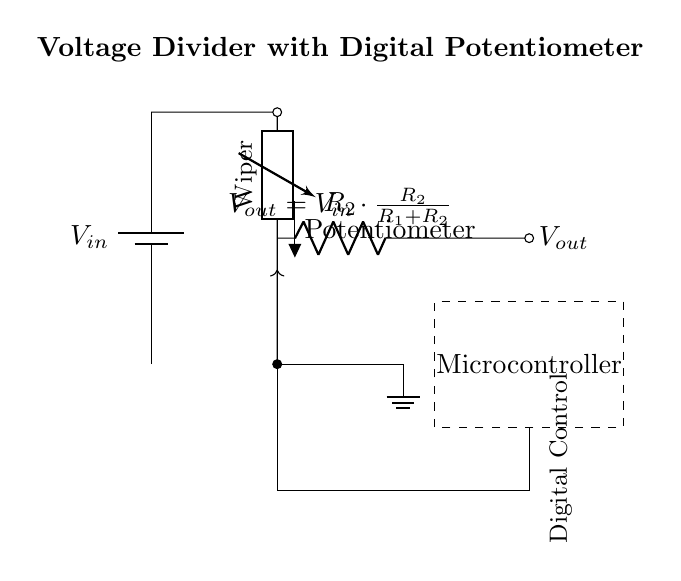What is the input voltage source? The input voltage source is labeled as V_in, indicating it is the voltage supplied to the circuit.
Answer: V_in What type of potentiometer is used in this circuit? The potentiometer is specified as a digital potentiometer, which is indicated by the label in the circuit design.
Answer: Digital What is the value of V_out based on the given formula? V_out is calculated using the formula V_out = V_in * (R_2 / (R_1 + R_2)), which relates the output voltage to the resistance values and input voltage.
Answer: V_out formula What role does the microcontroller play in this circuit? The microcontroller is responsible for controlling the digital potentiometer, adjusting the output voltage based on commands or settings it receives.
Answer: Control What is the purpose of the resistor labeled R_2? The resistor R_2 is part of the voltage divider network that, along with another resistor, determines the output voltage V_out relative to the input voltage V_in.
Answer: Voltage division How does changing the resistance of the digital potentiometer affect V_out? Adjusting the resistance of the digital potentiometer alters the ratio of R_2 to R_1, thus modifying V_out according to the voltage divider formula, allowing for precise control over the output voltage.
Answer: Affects output 